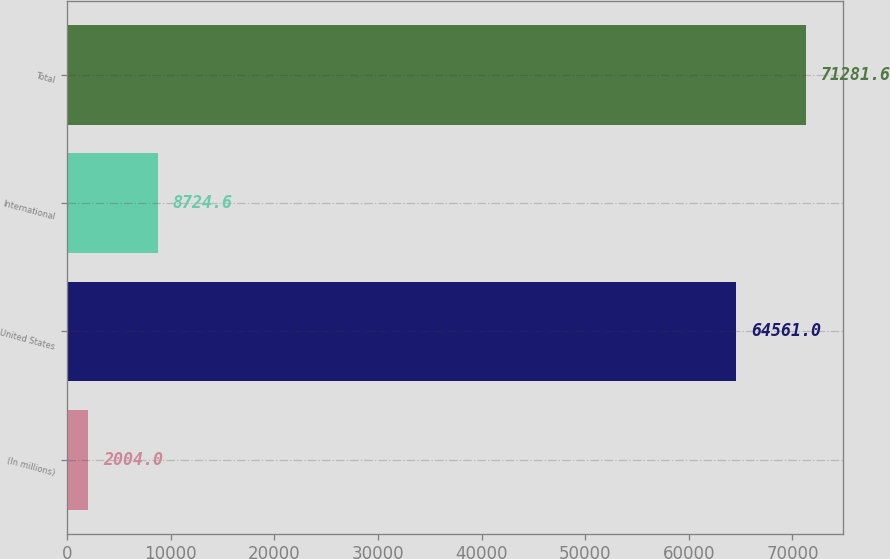Convert chart to OTSL. <chart><loc_0><loc_0><loc_500><loc_500><bar_chart><fcel>(In millions)<fcel>United States<fcel>International<fcel>Total<nl><fcel>2004<fcel>64561<fcel>8724.6<fcel>71281.6<nl></chart> 